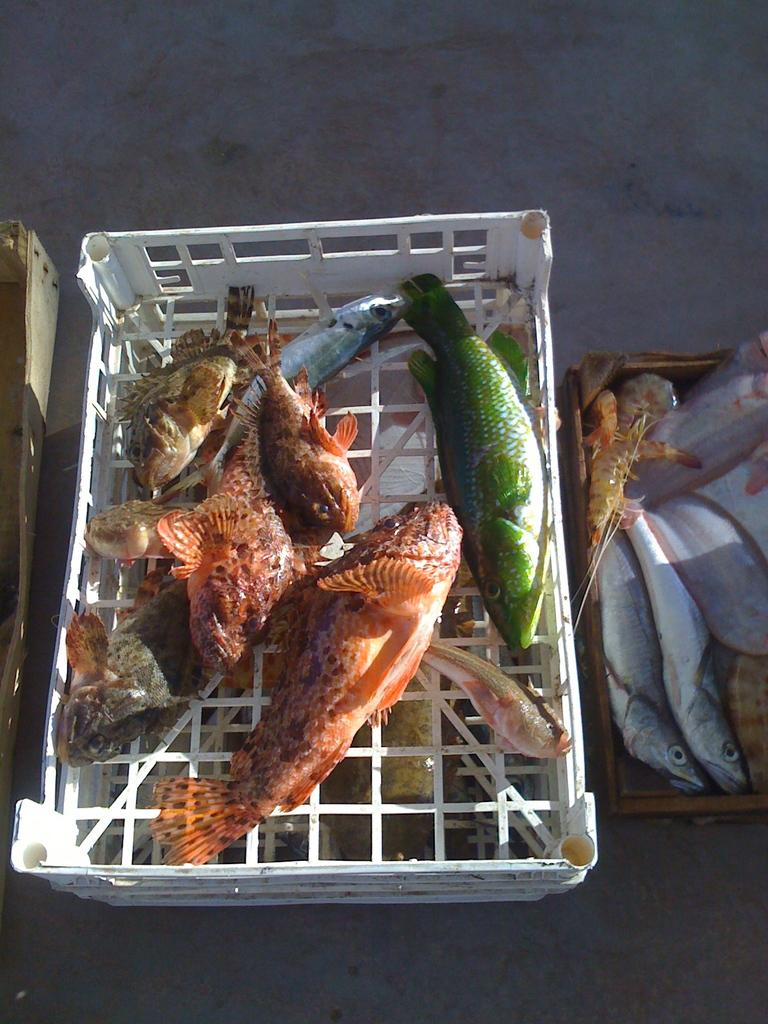What type of animals can be seen in the image? There are different colors of fishes in the image. Where are the fishes located? The fishes are in boxes. What is visible at the bottom of the image? There is a floor visible at the bottom of the image. What type of tree can be seen in the image? There is no tree present in the image; it features different colors of fishes in boxes. 